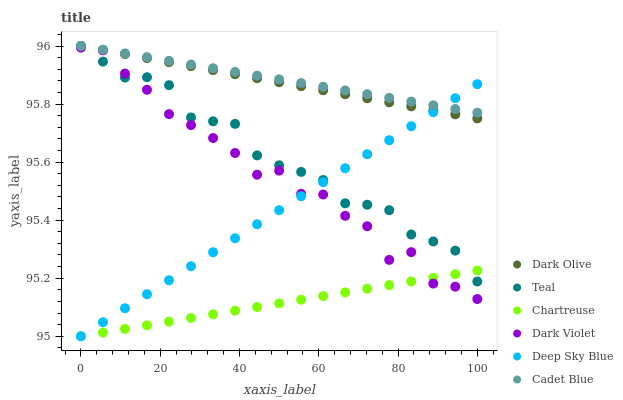Does Chartreuse have the minimum area under the curve?
Answer yes or no. Yes. Does Cadet Blue have the maximum area under the curve?
Answer yes or no. Yes. Does Teal have the minimum area under the curve?
Answer yes or no. No. Does Teal have the maximum area under the curve?
Answer yes or no. No. Is Dark Olive the smoothest?
Answer yes or no. Yes. Is Dark Violet the roughest?
Answer yes or no. Yes. Is Teal the smoothest?
Answer yes or no. No. Is Teal the roughest?
Answer yes or no. No. Does Chartreuse have the lowest value?
Answer yes or no. Yes. Does Teal have the lowest value?
Answer yes or no. No. Does Dark Olive have the highest value?
Answer yes or no. Yes. Does Dark Violet have the highest value?
Answer yes or no. No. Is Dark Violet less than Cadet Blue?
Answer yes or no. Yes. Is Dark Olive greater than Dark Violet?
Answer yes or no. Yes. Does Teal intersect Cadet Blue?
Answer yes or no. Yes. Is Teal less than Cadet Blue?
Answer yes or no. No. Is Teal greater than Cadet Blue?
Answer yes or no. No. Does Dark Violet intersect Cadet Blue?
Answer yes or no. No. 